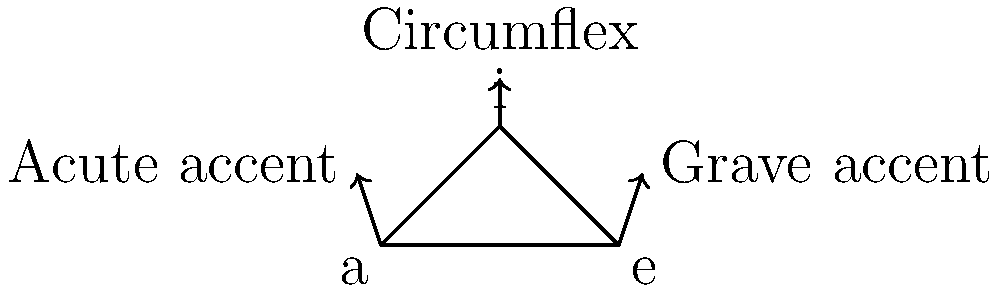In the development of diacritical marks for vowels in many European languages, which mark typically indicates a change in vowel quality rather than length, and is often used to denote a closed or tense vowel? To answer this question, let's consider the historical development of diacritical marks in European languages:

1. The acute accent (´) was originally used in Greek to mark a raised pitch or stress.
2. The grave accent (`) was used to mark a lowered pitch or the absence of stress.
3. The circumflex (ˆ) often indicated a long vowel or a contraction of two vowels.

In the evolution of these marks in various European languages:

1. The acute accent often came to indicate vowel length in languages like Czech and Hungarian.
2. The grave accent is used in French to distinguish homographs or to mark an open-mid vowel.
3. The circumflex, however, evolved differently in many languages:
   - In French, it often marks the historical loss of a consonant (usually 's').
   - In Portuguese, it marks a closed vowel.
   - In many other languages, it indicates a change in vowel quality rather than length.

The circumflex is most consistently used across languages to indicate a change in vowel quality, often denoting a more closed or tense pronunciation of the vowel. This is particularly evident in languages like Portuguese (ê, ô) and French (â, ê, ô).

Therefore, among these three common diacritical marks, the circumflex is the one that most typically indicates a change in vowel quality rather than length, and is often used to denote a closed or tense vowel.
Answer: Circumflex 